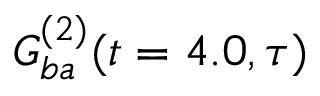Convert formula to latex. <formula><loc_0><loc_0><loc_500><loc_500>G _ { b a } ^ { ( 2 ) } ( t = 4 . 0 , \tau )</formula> 